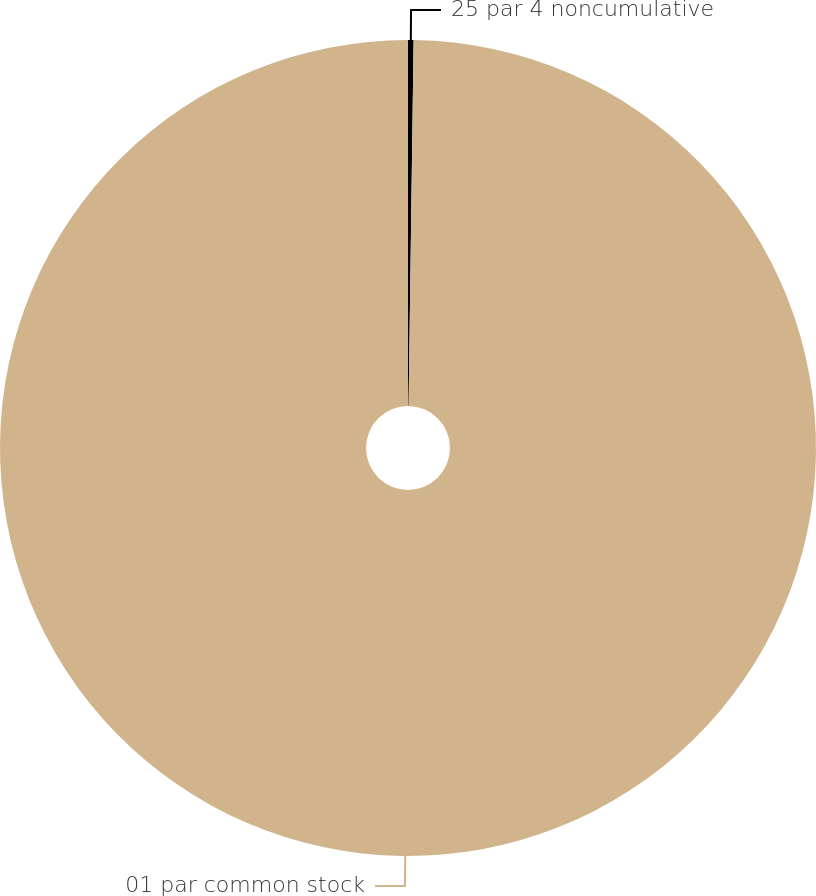Convert chart. <chart><loc_0><loc_0><loc_500><loc_500><pie_chart><fcel>25 par 4 noncumulative<fcel>01 par common stock<nl><fcel>0.22%<fcel>99.78%<nl></chart> 